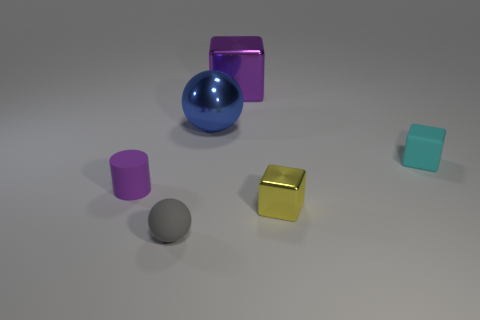Subtract all small yellow blocks. How many blocks are left? 2 Add 2 large matte balls. How many objects exist? 8 Subtract all yellow blocks. How many blocks are left? 2 Subtract all cylinders. How many objects are left? 5 Subtract 1 cylinders. How many cylinders are left? 0 Subtract all small cyan things. Subtract all tiny cylinders. How many objects are left? 4 Add 1 large purple blocks. How many large purple blocks are left? 2 Add 2 red metallic balls. How many red metallic balls exist? 2 Subtract 0 red blocks. How many objects are left? 6 Subtract all gray balls. Subtract all purple blocks. How many balls are left? 1 